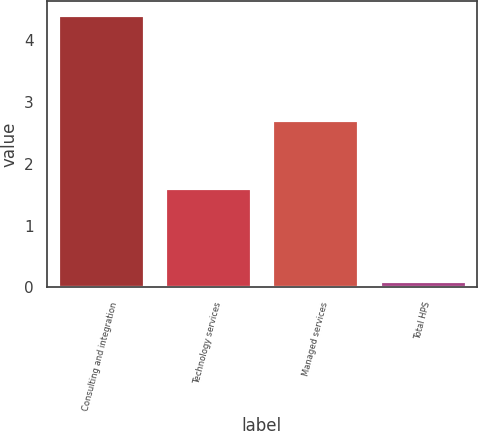Convert chart to OTSL. <chart><loc_0><loc_0><loc_500><loc_500><bar_chart><fcel>Consulting and integration<fcel>Technology services<fcel>Managed services<fcel>Total HPS<nl><fcel>4.4<fcel>1.6<fcel>2.7<fcel>0.1<nl></chart> 